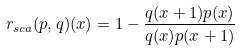<formula> <loc_0><loc_0><loc_500><loc_500>r _ { s c a } ( p , q ) ( x ) = 1 - \frac { q ( x + 1 ) p ( x ) } { q ( x ) p ( x + 1 ) }</formula> 